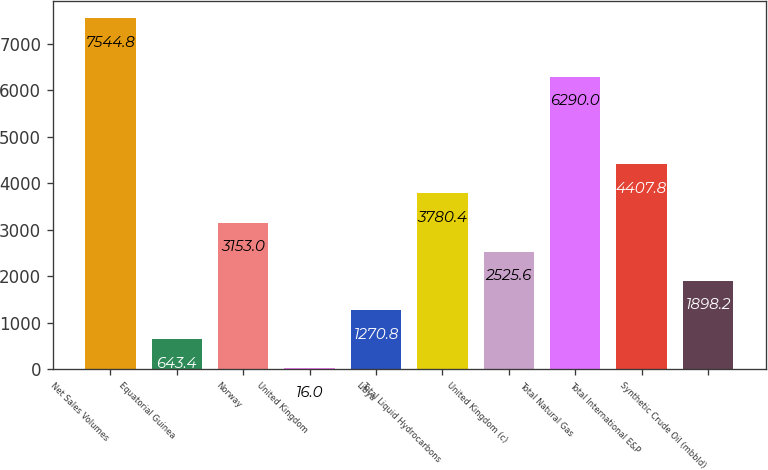Convert chart to OTSL. <chart><loc_0><loc_0><loc_500><loc_500><bar_chart><fcel>Net Sales Volumes<fcel>Equatorial Guinea<fcel>Norway<fcel>United Kingdom<fcel>Libya<fcel>Total Liquid Hydrocarbons<fcel>United Kingdom (c)<fcel>Total Natural Gas<fcel>Total International E&P<fcel>Synthetic Crude Oil (mbbld)<nl><fcel>7544.8<fcel>643.4<fcel>3153<fcel>16<fcel>1270.8<fcel>3780.4<fcel>2525.6<fcel>6290<fcel>4407.8<fcel>1898.2<nl></chart> 